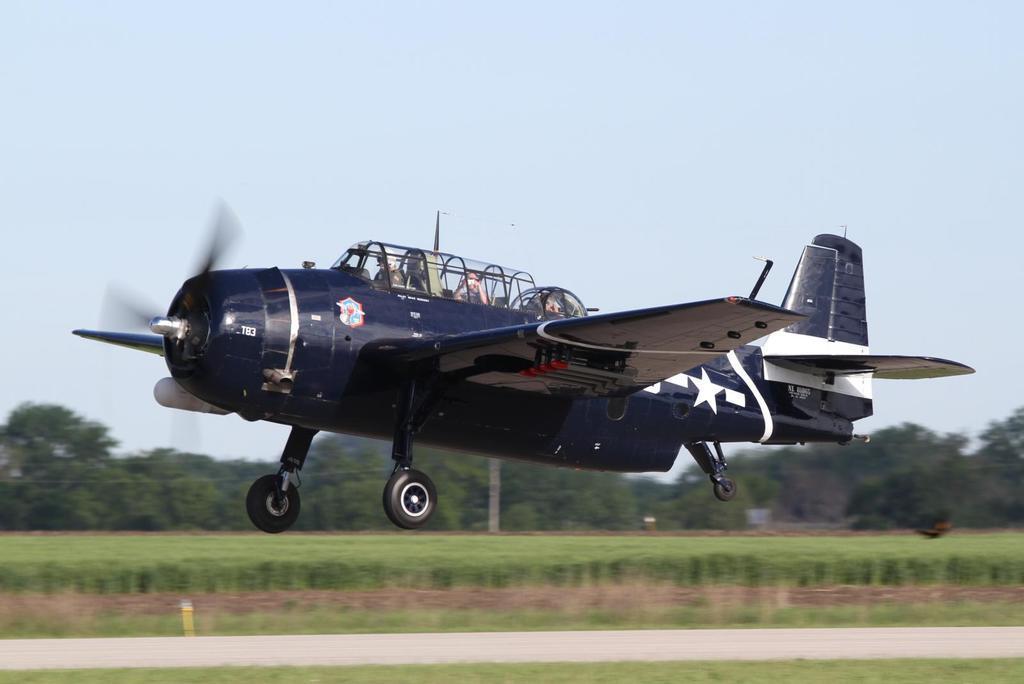Describe this image in one or two sentences. In this picture we can see an aircraft flying. Under the aircraft there is a runway and grass. Behind the grass, there are trees and the sky. There are three persons in the aircraft. 